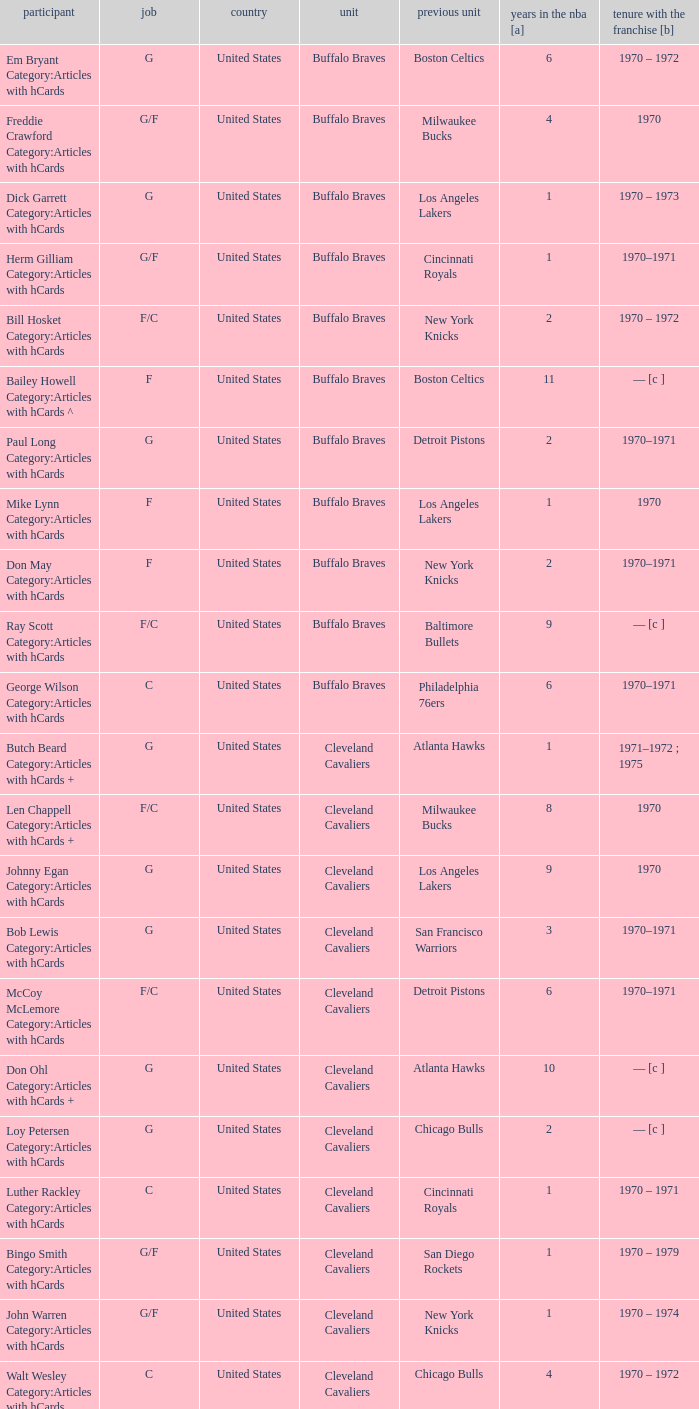Who is the player with 7 years of NBA experience? Larry Siegfried Category:Articles with hCards. 